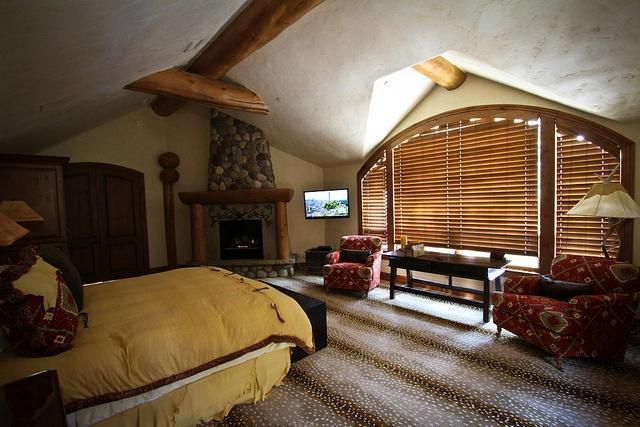Describe the objects in this image and their specific colors. I can see bed in black, olive, and maroon tones, chair in black, maroon, and gray tones, couch in black, maroon, and gray tones, dining table in black, maroon, white, and gray tones, and couch in black, maroon, and brown tones in this image. 